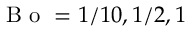<formula> <loc_0><loc_0><loc_500><loc_500>B o = 1 / 1 0 , 1 / 2 , 1</formula> 